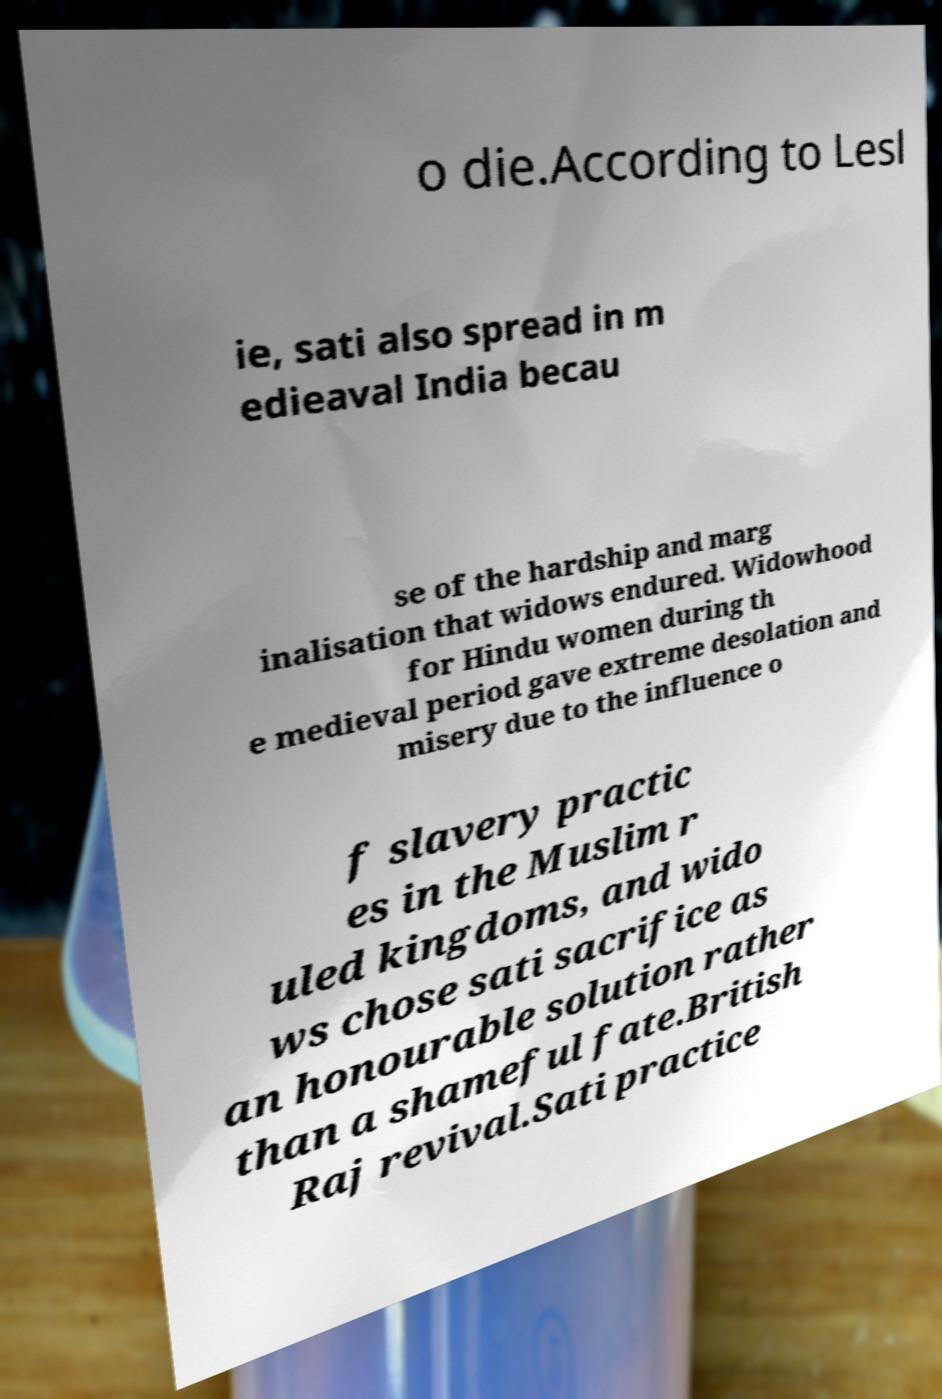Can you accurately transcribe the text from the provided image for me? o die.According to Lesl ie, sati also spread in m edieaval India becau se of the hardship and marg inalisation that widows endured. Widowhood for Hindu women during th e medieval period gave extreme desolation and misery due to the influence o f slavery practic es in the Muslim r uled kingdoms, and wido ws chose sati sacrifice as an honourable solution rather than a shameful fate.British Raj revival.Sati practice 